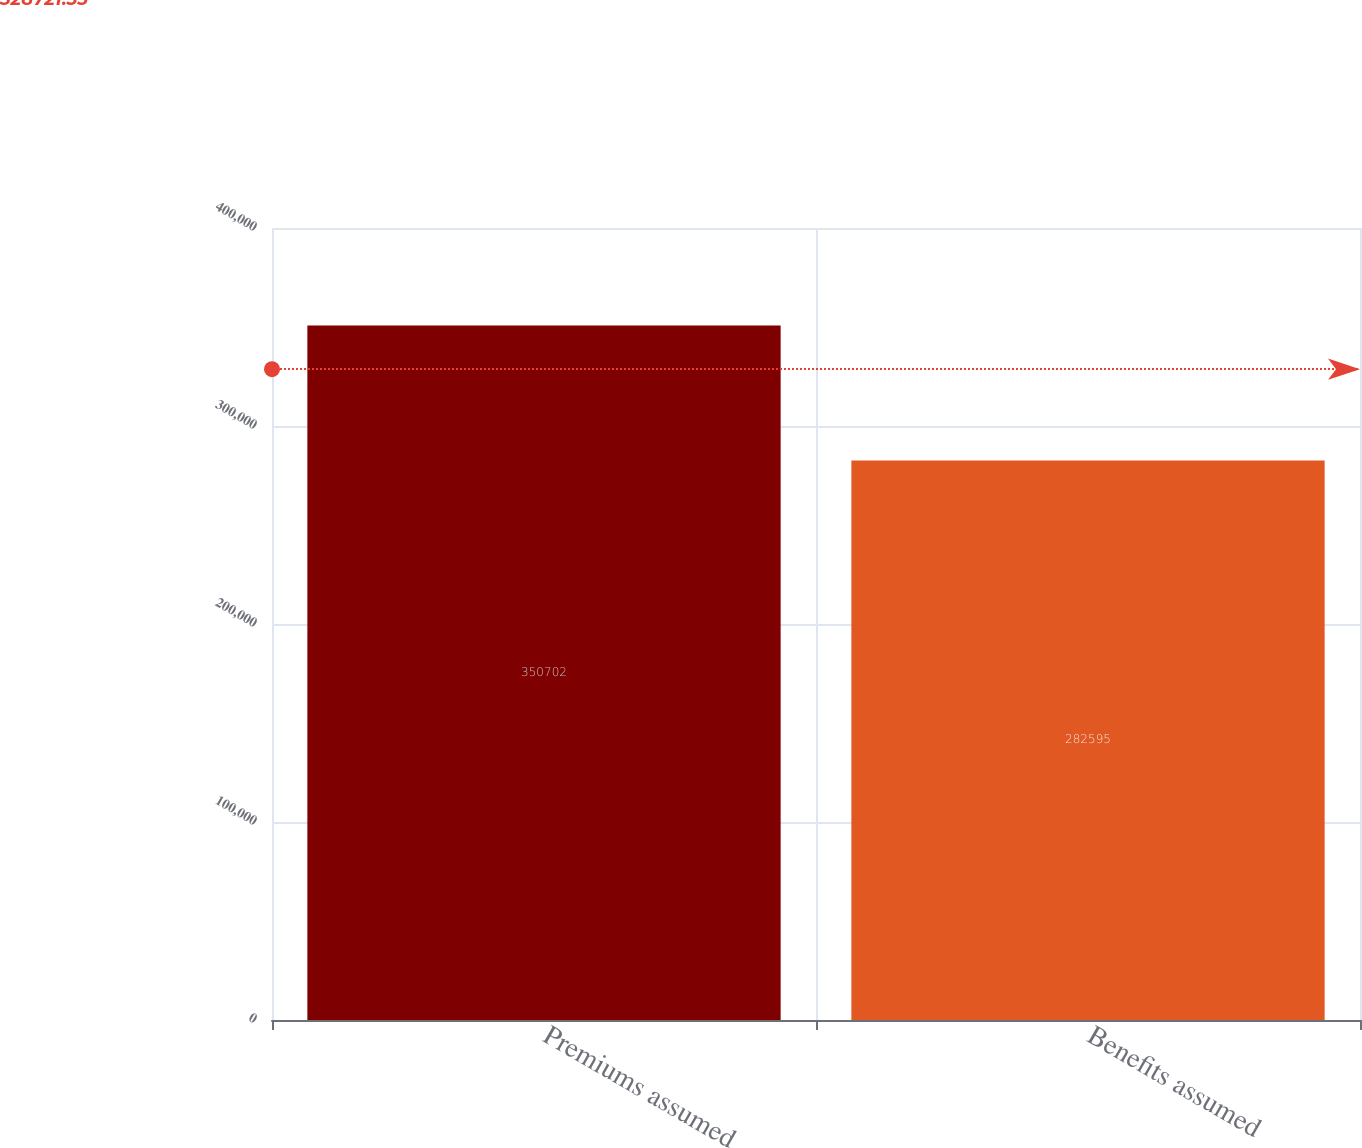Convert chart. <chart><loc_0><loc_0><loc_500><loc_500><bar_chart><fcel>Premiums assumed<fcel>Benefits assumed<nl><fcel>350702<fcel>282595<nl></chart> 